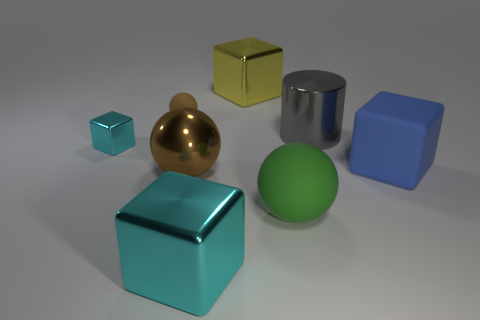Is the color of the big shiny cube that is in front of the brown matte sphere the same as the tiny metallic thing?
Your response must be concise. Yes. The brown thing that is the same size as the green rubber sphere is what shape?
Offer a very short reply. Sphere. The large green matte object has what shape?
Provide a succinct answer. Sphere. Do the cube that is in front of the big green ball and the tiny brown object have the same material?
Your answer should be compact. No. There is a ball that is behind the metallic block left of the brown rubber sphere; what is its size?
Ensure brevity in your answer.  Small. There is a big thing that is both in front of the gray cylinder and right of the big green matte object; what is its color?
Provide a succinct answer. Blue. What material is the cyan thing that is the same size as the green rubber thing?
Offer a terse response. Metal. What number of other objects are there of the same material as the big cyan thing?
Ensure brevity in your answer.  4. Do the large object that is to the left of the big cyan metal object and the big cube that is to the right of the big yellow metal cube have the same color?
Your answer should be compact. No. What shape is the large metallic thing in front of the rubber sphere right of the small ball?
Your response must be concise. Cube. 